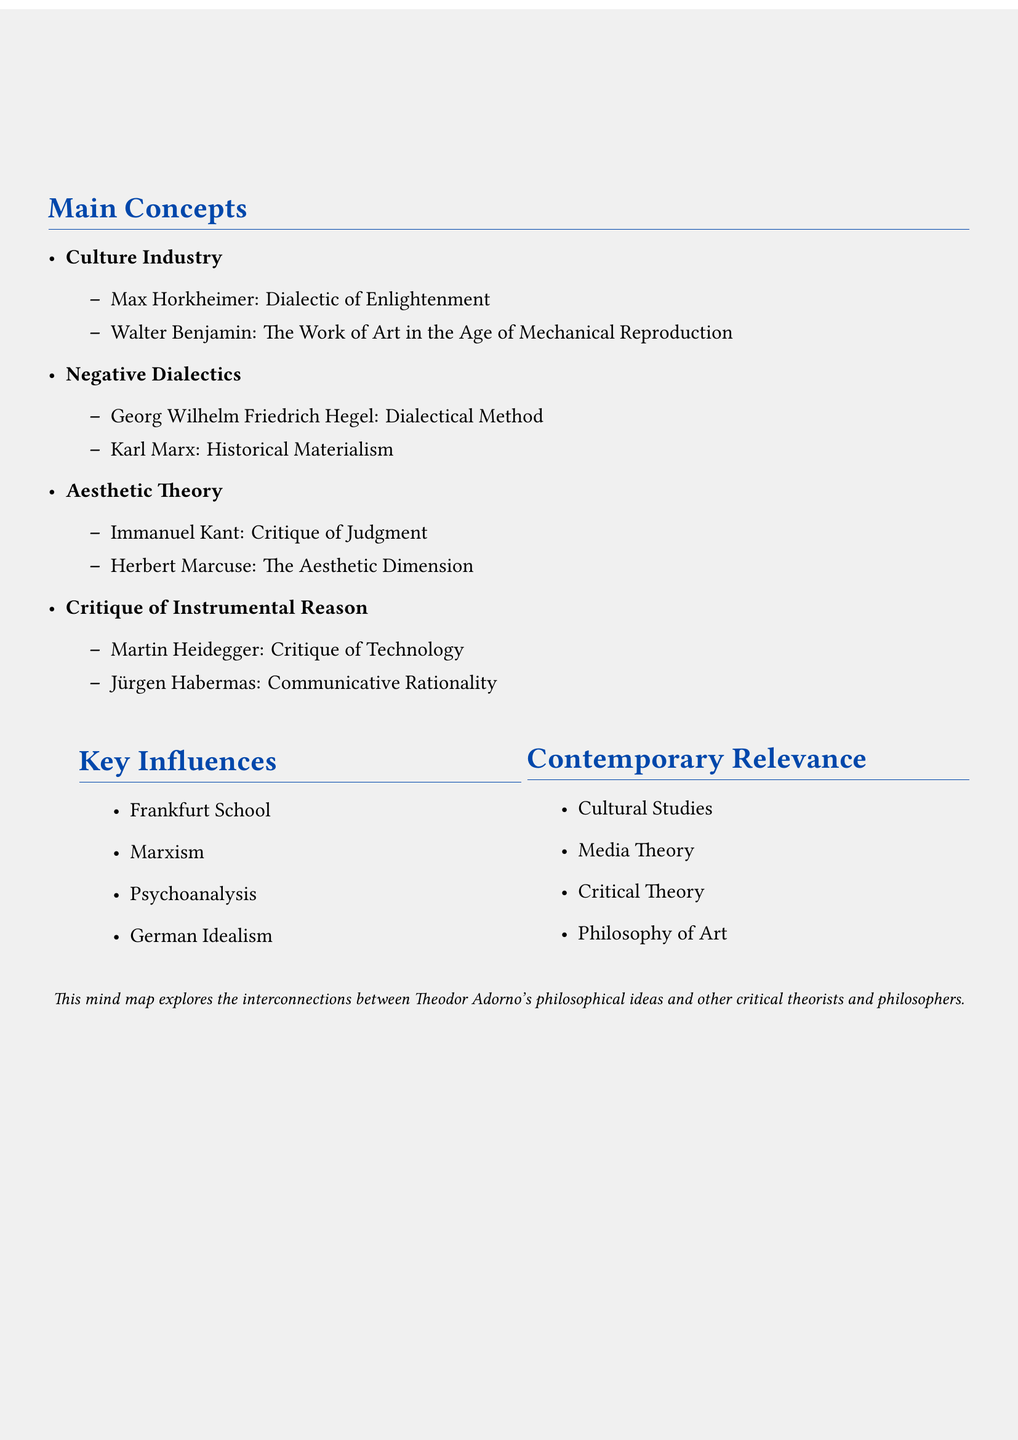What is the central concept of the mind map? The central concept provides the overarching theme of the mind map, which is Theodor Adorno's Ideas.
Answer: Theodor Adorno's Ideas Who is connected to the concept of Culture Industry? The document lists the theorists connected to the Culture Industry concept, specifically naming Max Horkheimer and Walter Benjamin.
Answer: Max Horkheimer, Walter Benjamin What does Adorno critique in his concept of Critique of Instrumental Reason? The document includes connections to key theorists related to this concept, specifically Martin Heidegger and Jürgen Habermas.
Answer: Technology, Communicative Rationality Which philosopher's idea is related to Negative Dialectics? In the mind map, Georg Wilhelm Friedrich Hegel is mentioned in connection with Negative Dialectics.
Answer: Georg Wilhelm Friedrich Hegel What influential school is associated with Adorno's ideas? The document identifies key influences, one being the Frankfurt School, which is critical in understanding his work.
Answer: Frankfurt School What contemporary field is mentioned in connection with Adorno? The document lists several contemporary relevance areas, one being Cultural Studies, which illustrates how Adorno's ideas are applicable today.
Answer: Cultural Studies What concept is linked with Immanuel Kant in Adorno's Aesthetic Theory? The mind map connects Immanuel Kant's philosophy to Adorno's Aesthetic Theory, specifically mentioning his work titled Critique of Judgment.
Answer: Critique of Judgment How many main branches are there under Adorno's Ideas? The document details four main branches, indicating a structured approach to connecting his ideas with others.
Answer: Four Which critical theorist is associated with Historical Materialism? The document connects Karl Marx to the concept of Historical Materialism in relation to Adorno's Negative Dialectics.
Answer: Karl Marx 